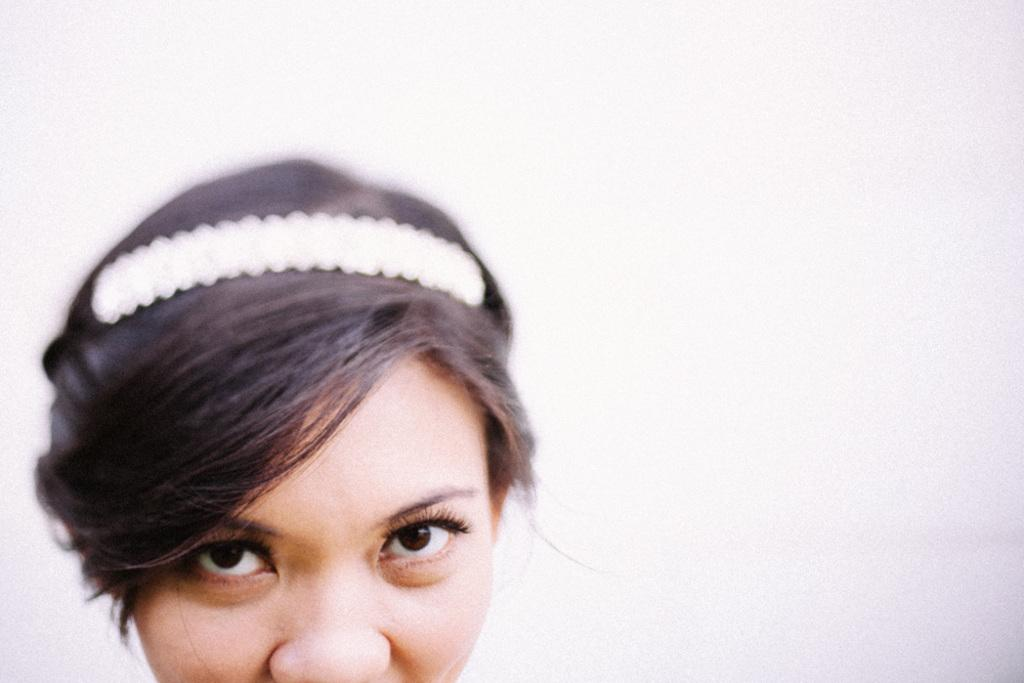What is depicted on the left side of the image? There is a picture of a woman in the image, and it is on the left side. What can be observed about the woman in the picture? The woman in the picture has hair and is wearing a belt. What is the color of the background in the image? The background of the image is white. What type of curtain can be seen hanging in the image? There is no curtain present in the image; it features a picture of a woman with a white background. How much sugar is visible in the image? There is no sugar present in the image. 